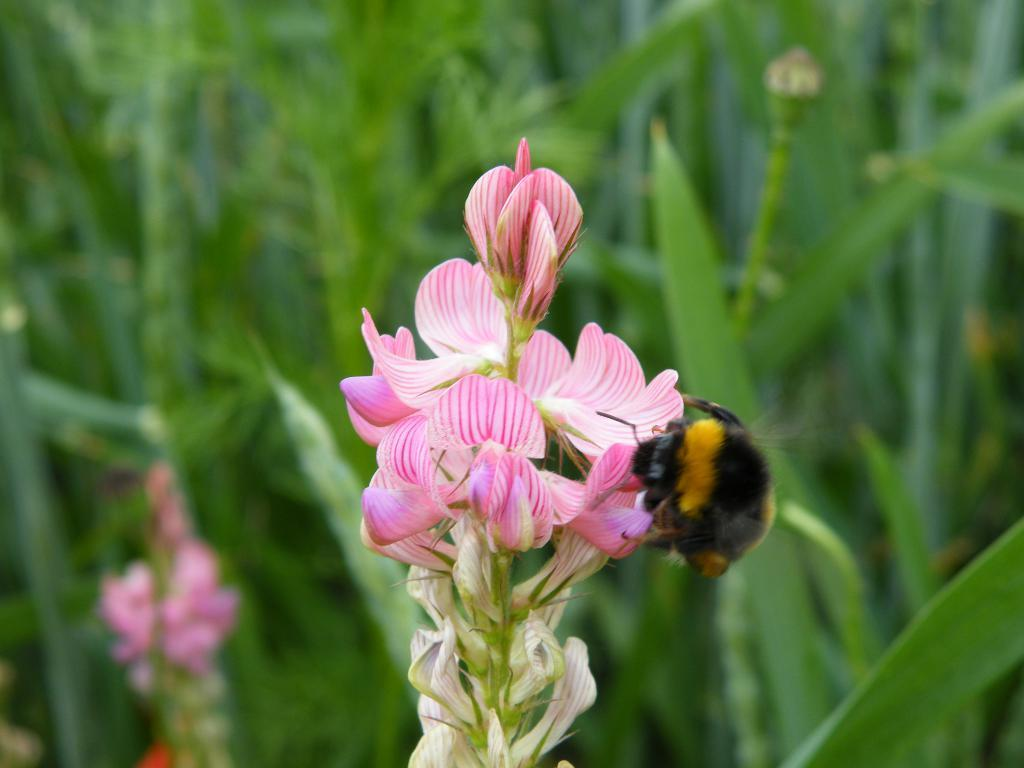What type of flora can be seen in the image? There are flowers in the image. What color are the flowers? The flowers are pink in color. Are there any insects present in the image? Yes, there is a honey bee on the flowers. What can be seen in the background of the image? There are plants in the background of the image. How is the background of the image depicted? The background is blurred. What type of fact can be seen burning in the image? There is no fact present in the image, nor is anything depicted as burning. 